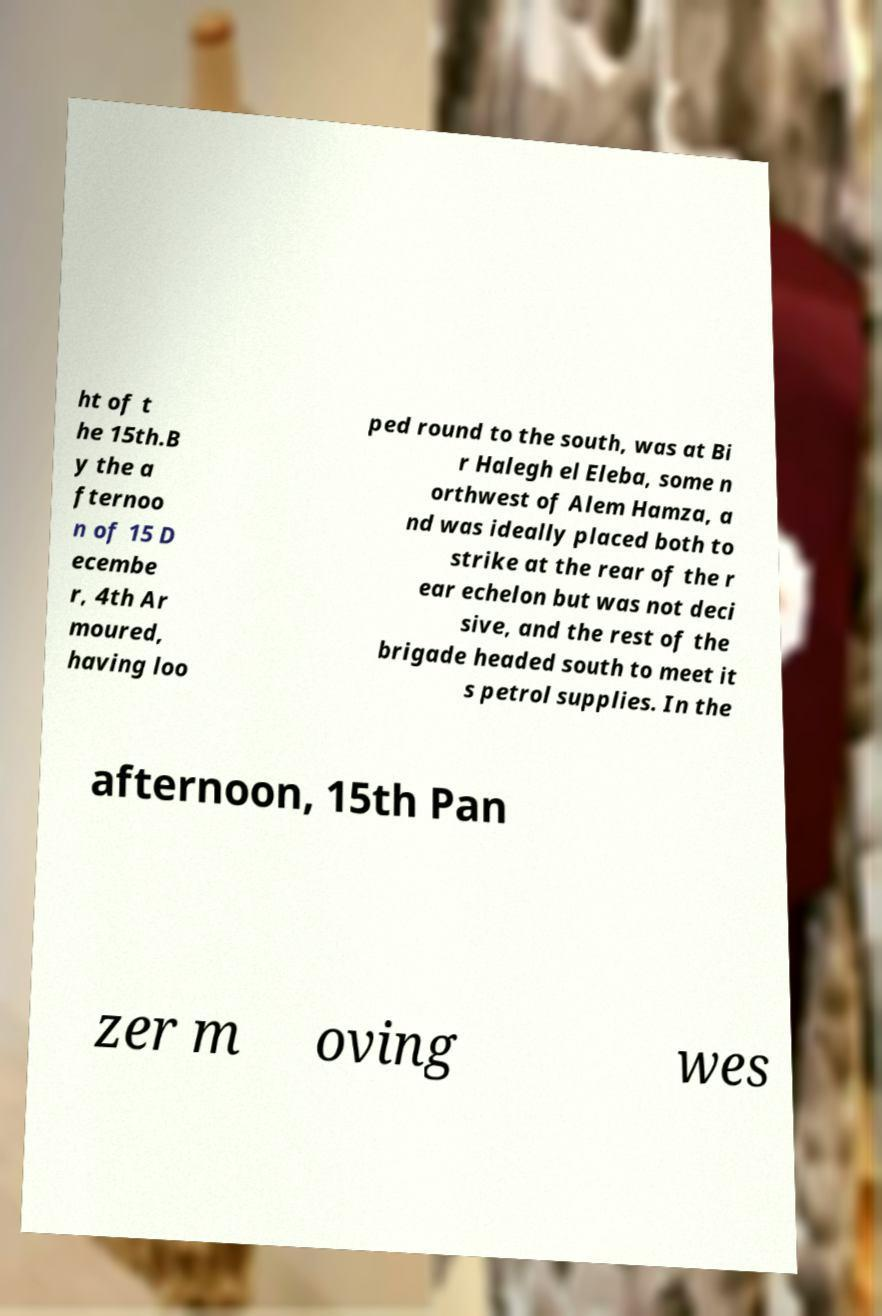Please identify and transcribe the text found in this image. ht of t he 15th.B y the a fternoo n of 15 D ecembe r, 4th Ar moured, having loo ped round to the south, was at Bi r Halegh el Eleba, some n orthwest of Alem Hamza, a nd was ideally placed both to strike at the rear of the r ear echelon but was not deci sive, and the rest of the brigade headed south to meet it s petrol supplies. In the afternoon, 15th Pan zer m oving wes 